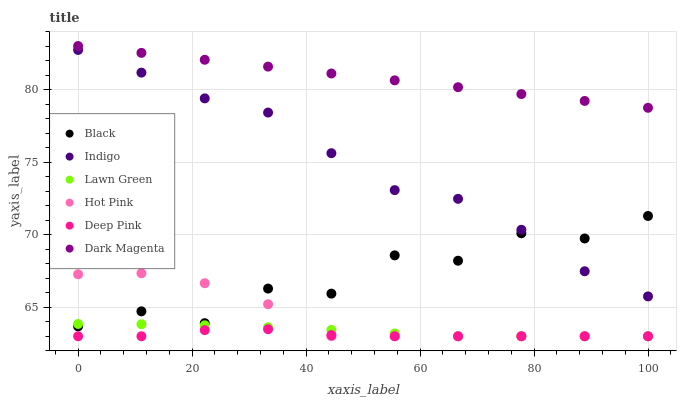Does Deep Pink have the minimum area under the curve?
Answer yes or no. Yes. Does Dark Magenta have the maximum area under the curve?
Answer yes or no. Yes. Does Indigo have the minimum area under the curve?
Answer yes or no. No. Does Indigo have the maximum area under the curve?
Answer yes or no. No. Is Dark Magenta the smoothest?
Answer yes or no. Yes. Is Black the roughest?
Answer yes or no. Yes. Is Deep Pink the smoothest?
Answer yes or no. No. Is Deep Pink the roughest?
Answer yes or no. No. Does Lawn Green have the lowest value?
Answer yes or no. Yes. Does Indigo have the lowest value?
Answer yes or no. No. Does Dark Magenta have the highest value?
Answer yes or no. Yes. Does Indigo have the highest value?
Answer yes or no. No. Is Deep Pink less than Dark Magenta?
Answer yes or no. Yes. Is Dark Magenta greater than Black?
Answer yes or no. Yes. Does Indigo intersect Black?
Answer yes or no. Yes. Is Indigo less than Black?
Answer yes or no. No. Is Indigo greater than Black?
Answer yes or no. No. Does Deep Pink intersect Dark Magenta?
Answer yes or no. No. 